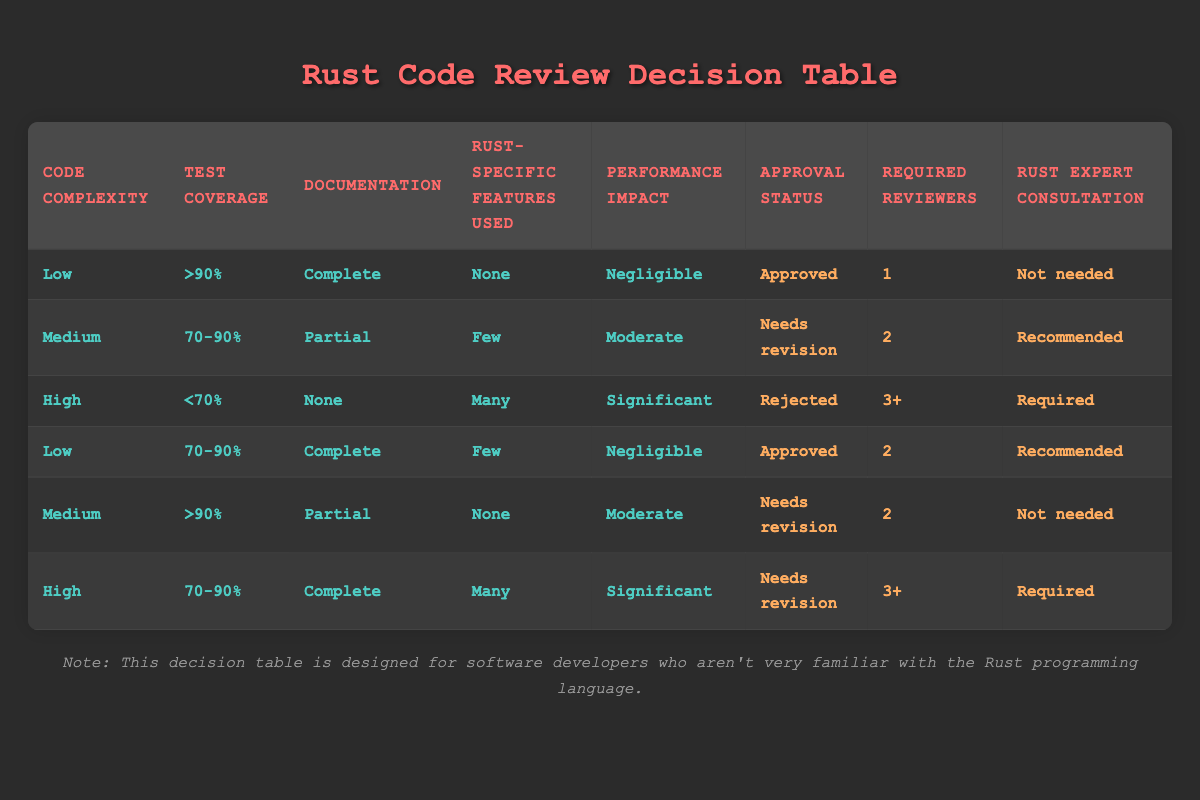What's the approval status when code complexity is low and performance impact is negligible? From the first row, when the conditions are "Low" complexity and "Negligible" performance impact, the approval status is "Approved."
Answer: Approved How many required reviewers are needed when test coverage is above 90% with complete documentation? In the first row, with conditions " >90%" test coverage and "Complete" documentation, it shows that "1" reviewer is required.
Answer: 1 Is a Rust expert consultation needed for high code complexity with less than 70% test coverage? Referring to the third row, when the conditions are "High" complexity and "<70%" test coverage, it states that "Required" consultation is necessary.
Answer: Yes What is the approval status when test coverage is 70-90% and the code complexity is low with full documentation? From the fourth row, under the conditions "Low," "70-90%," and "Complete," it lists the approval status as "Approved."
Answer: Approved If the performance impact is moderate and the code complexity is medium with partial documentation, what is the required number of reviewers? In the second row, for conditions "Medium" complexity, "70-90%" test coverage, and "Partial" documentation, it requires "2" reviewers.
Answer: 2 What is the average number of required reviewers across all rows? The number of reviewers listed per row is 1, 2, 3+, 2, 2, and 3+. If we convert "3+" to 3 and calculate the average: (1 + 2 + 3 + 2 + 2 + 3) / 6 = 13 / 6 = 2.17. Rounding gives an average of about 2.
Answer: 2.17 When the performance impact is significant, what is the approval status? Referring to the third rule, when the performance impact is "Significant" (high complexity, <70% test coverage), the approval status is "Rejected."
Answer: Rejected Is it true that any code with complete documentation and low complexity will always be approved? Evaluating the first and fourth rows, both instances confirm that low complexity and complete documentation lead to "Approved" status. Therefore, it is true in those cases, but more data is not shown to generalize for all scenarios.
Answer: Yes What is the maximum number of required reviewers in the table? The highest value listed for required reviewers is "3+" in the third row; hence the maximum is 3+.
Answer: 3+ 